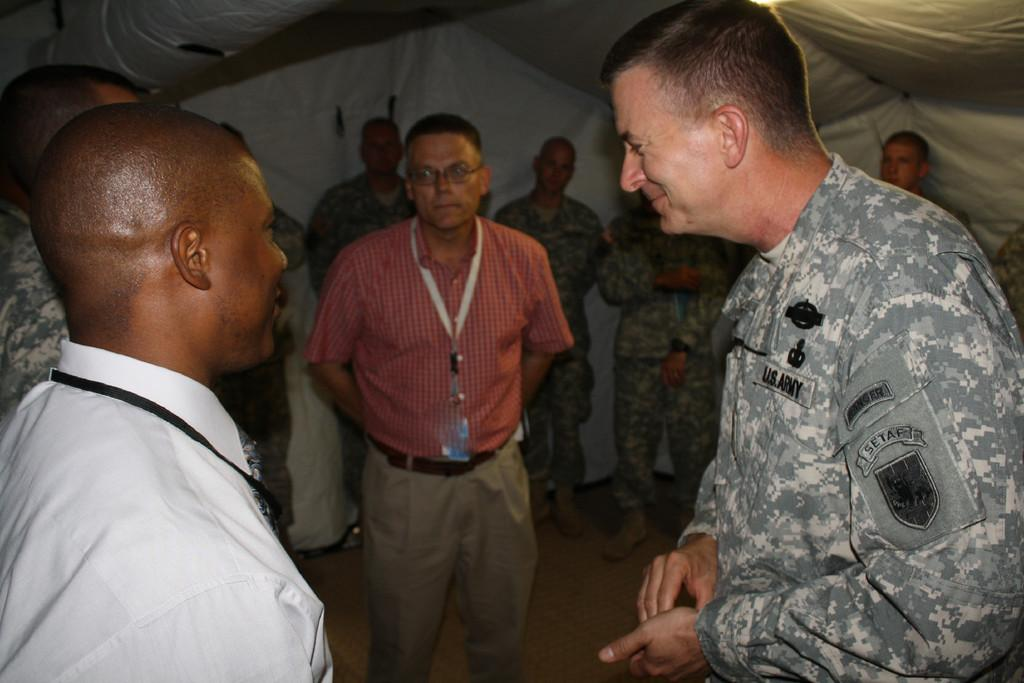Where was the image taken? The image was taken inside a room. What can be seen in the room? There is a group of people standing in the image. Is there any other object or structure visible in the room? Yes, there is a tent visible at the top of the image. What is the price of the machine in the image? There is no machine present in the image, so it is not possible to determine its price. 